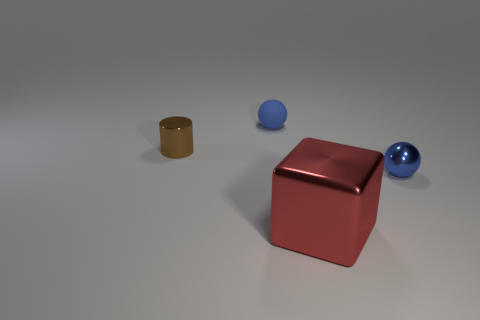There is a tiny sphere that is behind the brown thing left of the large shiny block; what color is it?
Ensure brevity in your answer.  Blue. What number of other objects are there of the same color as the matte ball?
Keep it short and to the point. 1. The red shiny block is what size?
Your answer should be very brief. Large. Are there more red objects in front of the blue matte object than large shiny cubes that are behind the small brown cylinder?
Provide a succinct answer. Yes. There is a sphere to the right of the tiny matte sphere; how many tiny matte things are on the right side of it?
Your answer should be very brief. 0. There is a blue thing that is behind the tiny blue metal thing; does it have the same shape as the small blue shiny thing?
Your answer should be very brief. Yes. There is another small thing that is the same shape as the blue metallic thing; what is its material?
Make the answer very short. Rubber. What number of blocks have the same size as the brown metallic object?
Your answer should be compact. 0. What color is the thing that is both behind the big metal block and in front of the brown cylinder?
Give a very brief answer. Blue. Is the number of brown shiny objects less than the number of gray metallic cylinders?
Keep it short and to the point. No. 